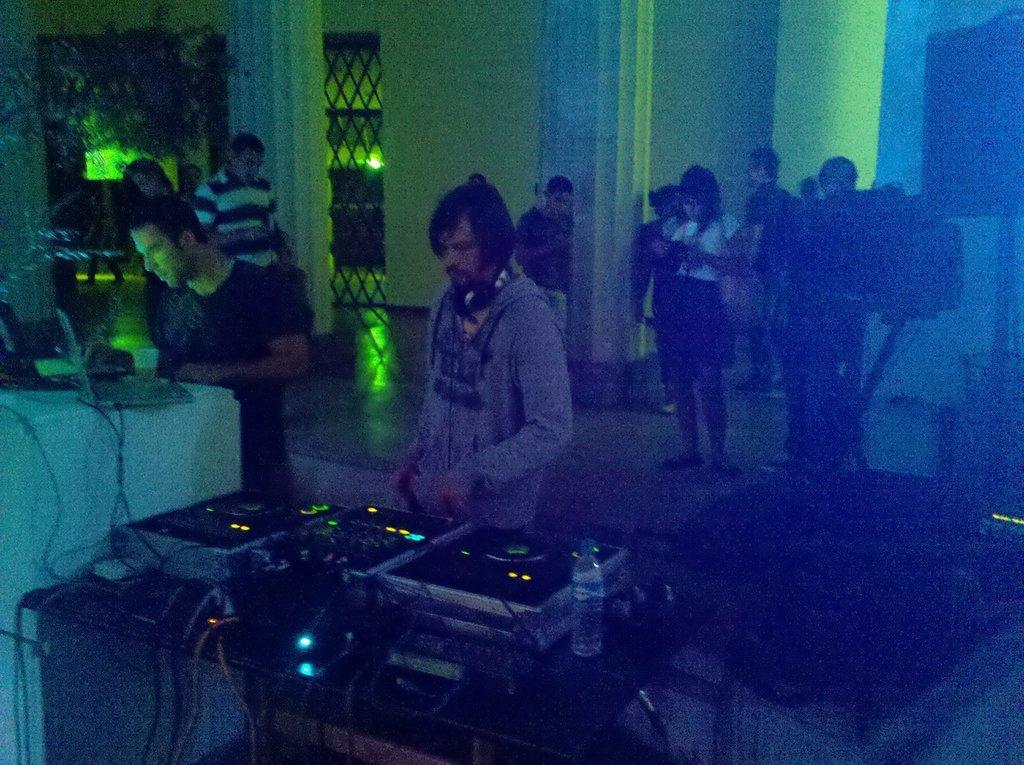Can you describe this image briefly? In the center of the image we can see a man playing dj, next to him there is a man standing. We can see a table and there are laptops placed on the table. In the background there are people, wall, gate and lights. 